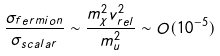<formula> <loc_0><loc_0><loc_500><loc_500>\frac { \sigma _ { f e r m i o n } } { \sigma _ { s c a l a r } } \sim \frac { m _ { \chi } ^ { 2 } v _ { r e l } ^ { 2 } } { m _ { u } ^ { 2 } } \sim O ( 1 0 ^ { - 5 } )</formula> 